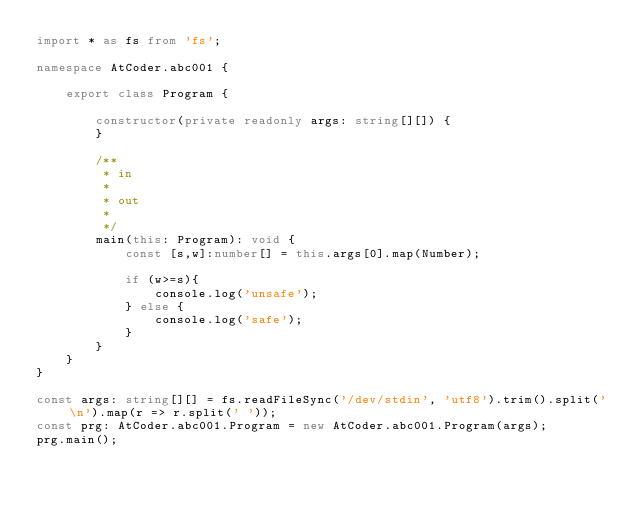<code> <loc_0><loc_0><loc_500><loc_500><_TypeScript_>import * as fs from 'fs';

namespace AtCoder.abc001 {

    export class Program {

        constructor(private readonly args: string[][]) {
        }

        /**
         * in
         *
         * out
         *
         */
        main(this: Program): void {
            const [s,w]:number[] = this.args[0].map(Number);

            if (w>=s){
                console.log('unsafe');
            } else {
                console.log('safe');
            }
        }
    }
}

const args: string[][] = fs.readFileSync('/dev/stdin', 'utf8').trim().split('\n').map(r => r.split(' '));
const prg: AtCoder.abc001.Program = new AtCoder.abc001.Program(args);
prg.main();
</code> 